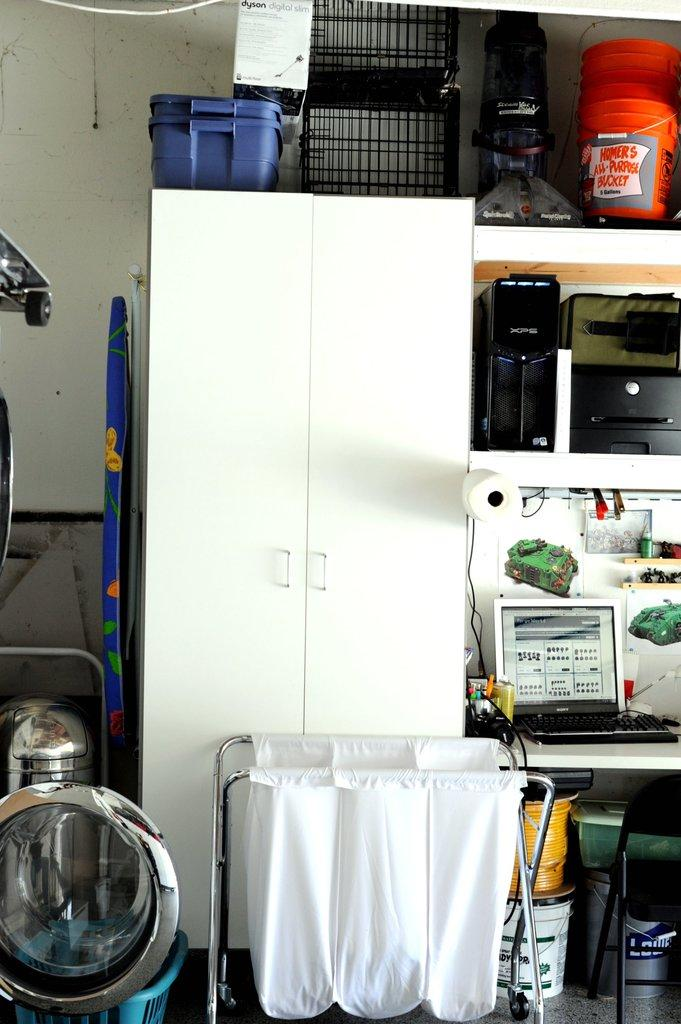<image>
Present a compact description of the photo's key features. A storage room with disarray of things are shown including a white cabinet, hamper, and shelves with a bucket that says "Homer's All Purpose bucket." 